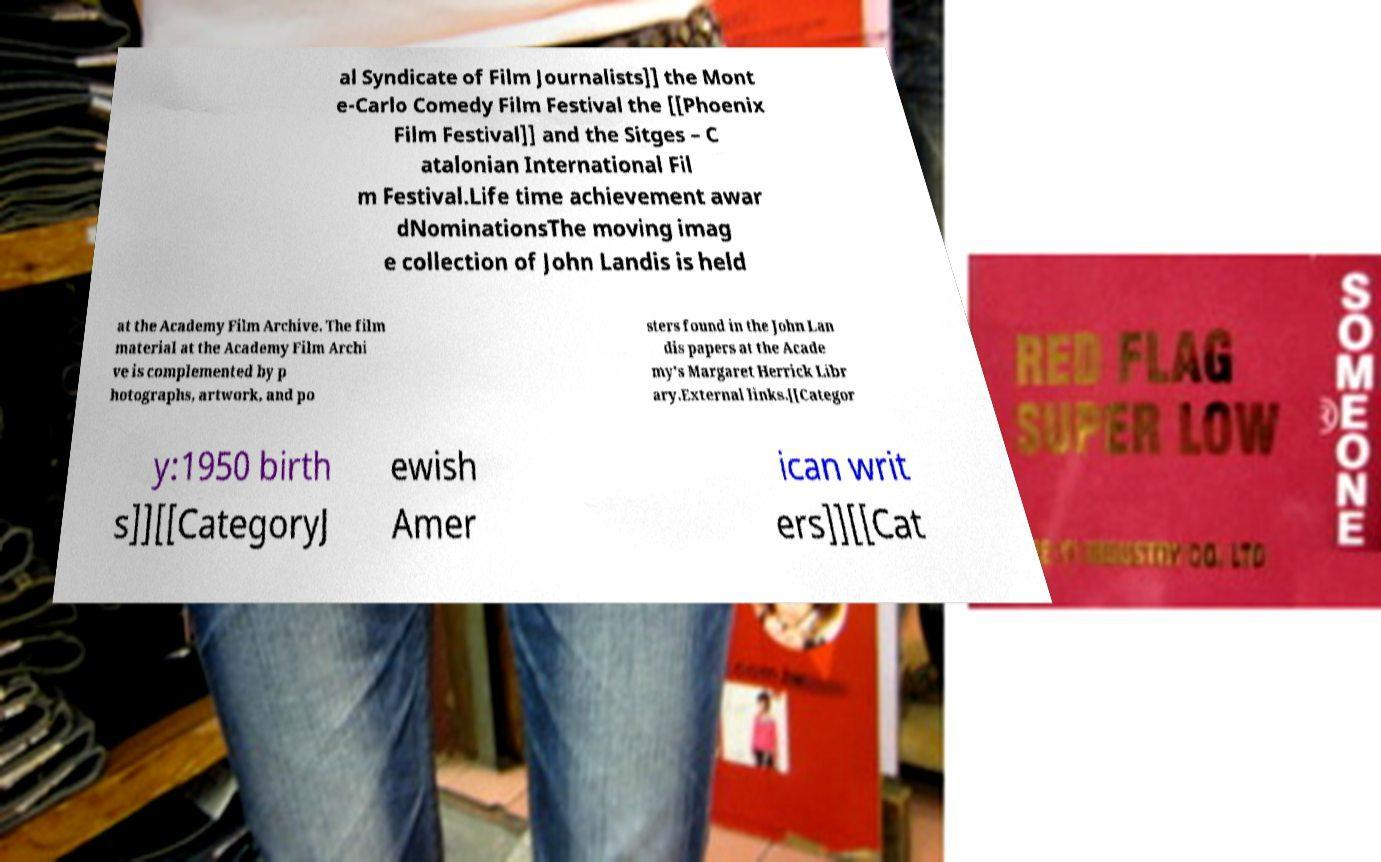Can you read and provide the text displayed in the image?This photo seems to have some interesting text. Can you extract and type it out for me? al Syndicate of Film Journalists]] the Mont e-Carlo Comedy Film Festival the [[Phoenix Film Festival]] and the Sitges – C atalonian International Fil m Festival.Life time achievement awar dNominationsThe moving imag e collection of John Landis is held at the Academy Film Archive. The film material at the Academy Film Archi ve is complemented by p hotographs, artwork, and po sters found in the John Lan dis papers at the Acade my's Margaret Herrick Libr ary.External links.[[Categor y:1950 birth s]][[CategoryJ ewish Amer ican writ ers]][[Cat 